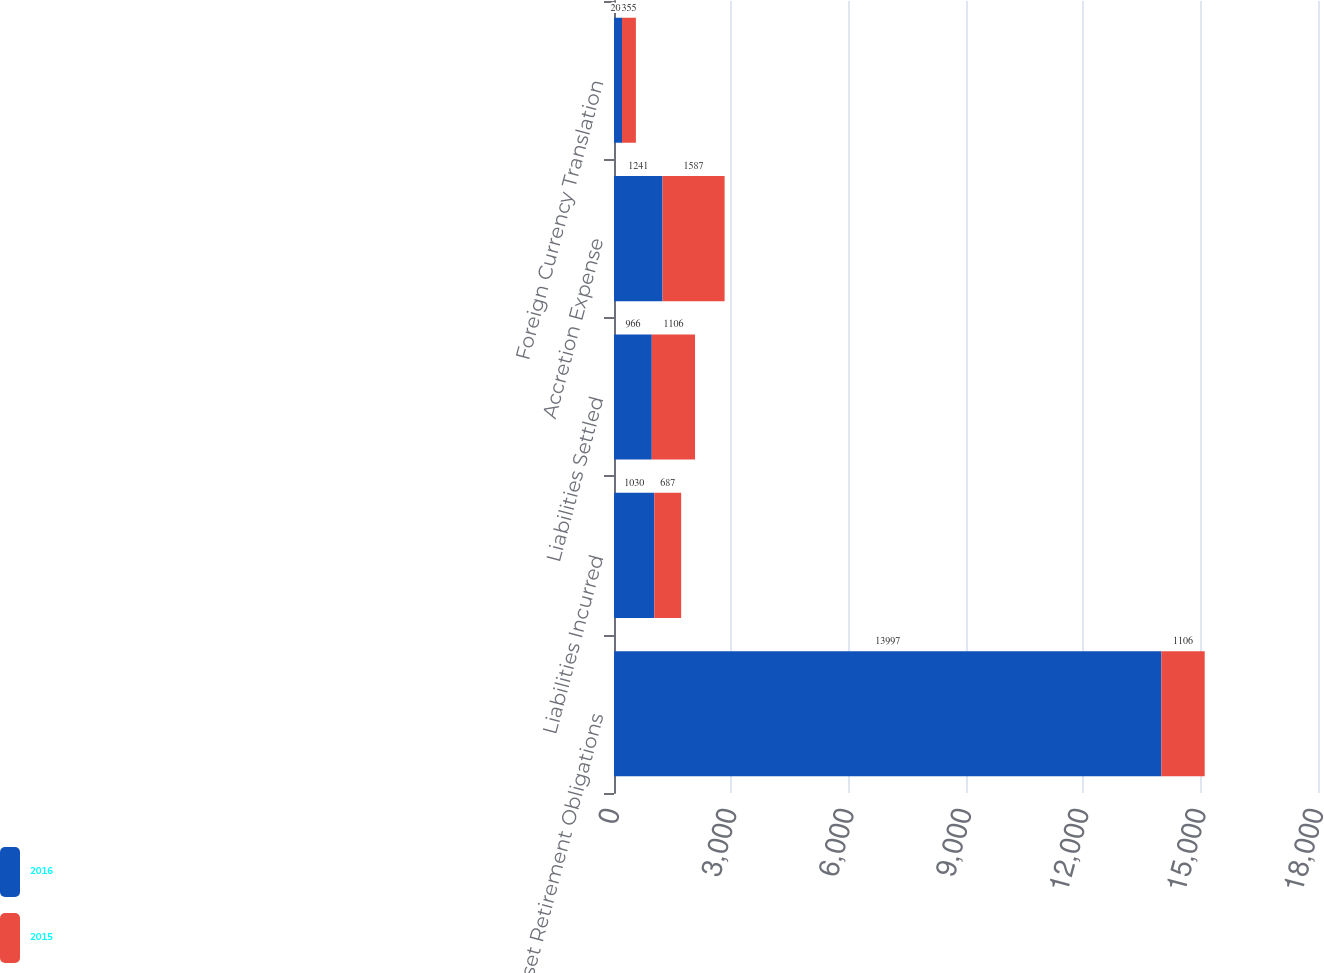<chart> <loc_0><loc_0><loc_500><loc_500><stacked_bar_chart><ecel><fcel>Asset Retirement Obligations<fcel>Liabilities Incurred<fcel>Liabilities Settled<fcel>Accretion Expense<fcel>Foreign Currency Translation<nl><fcel>2016<fcel>13997<fcel>1030<fcel>966<fcel>1241<fcel>205<nl><fcel>2015<fcel>1106<fcel>687<fcel>1106<fcel>1587<fcel>355<nl></chart> 